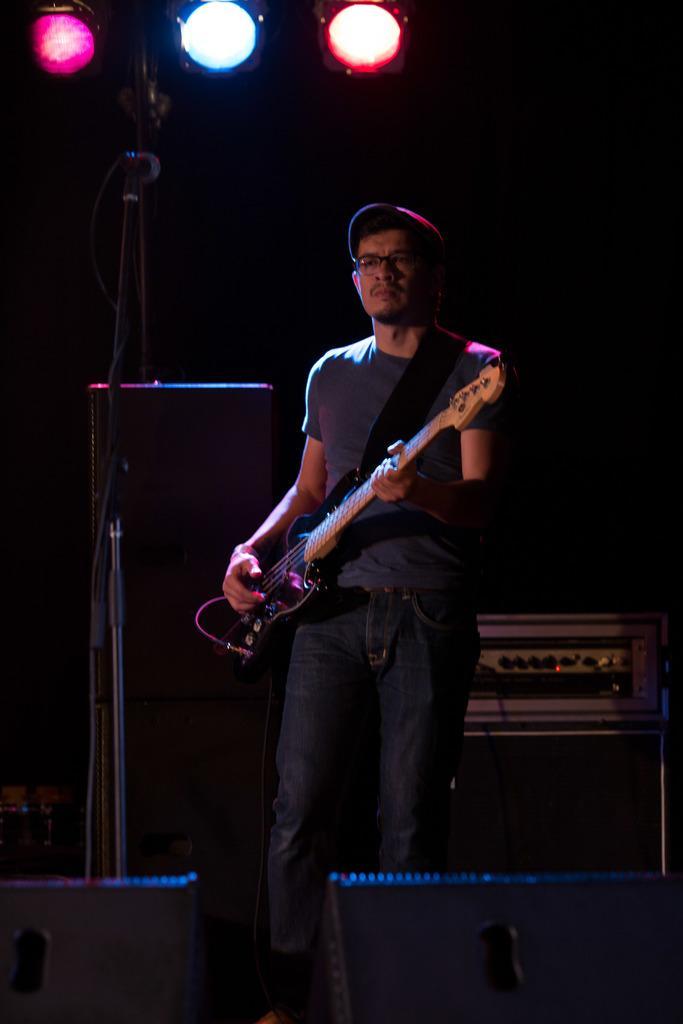How would you summarize this image in a sentence or two? In the image we can see there is a man who is standing and holding guitar in his hand. 